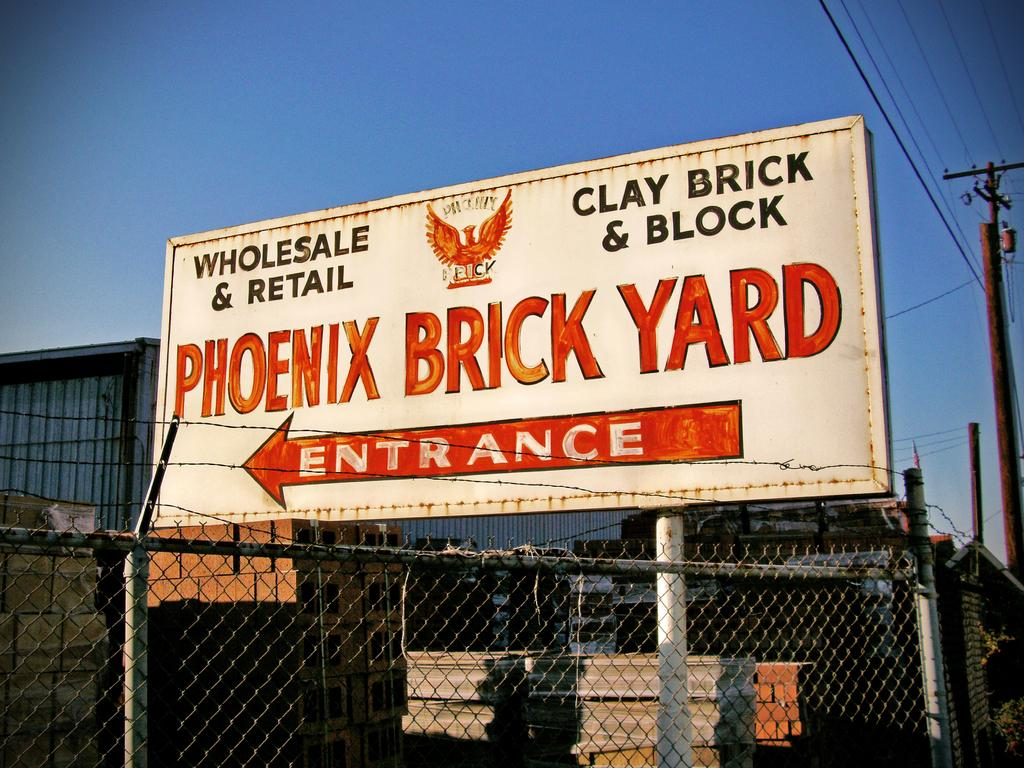<image>
Relay a brief, clear account of the picture shown. Sign in the back of a fence that says Phoenix Brick Yard Entrance to the left. 